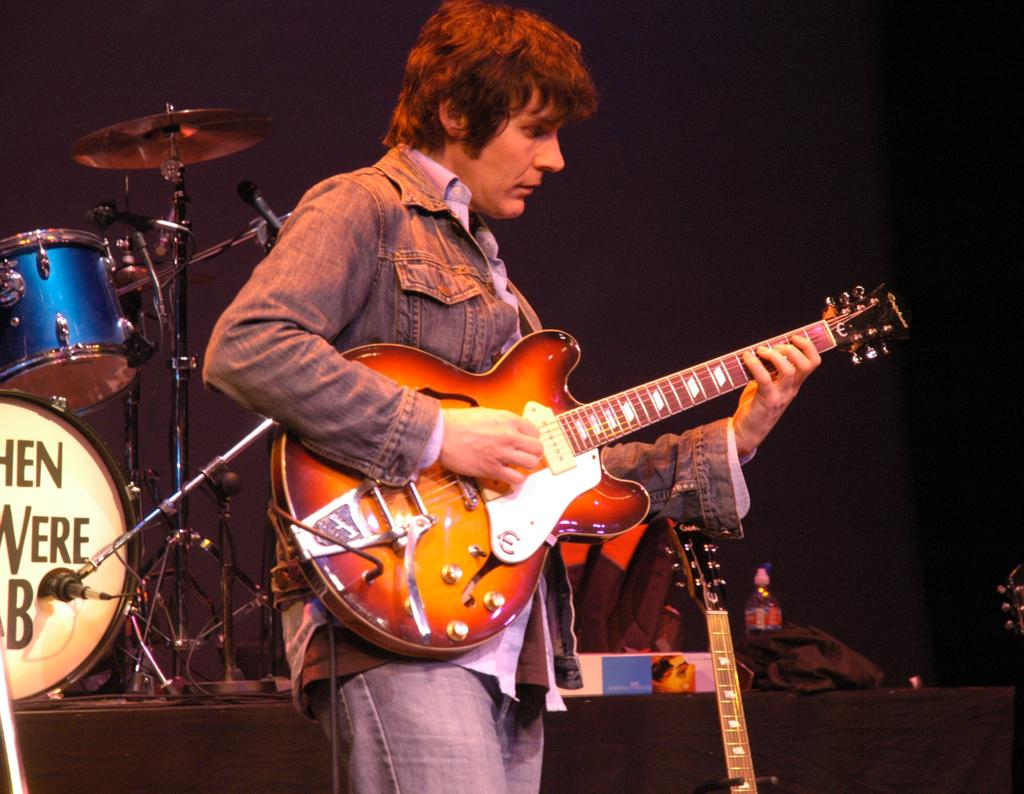What is the main activity of the person in the image? The person in the image is playing a guitar. Are there any other guitars visible in the image? Yes, there is another guitar beside the person. What other musical instrument can be seen in the image? There is a musical instrument behind the person. Can you describe the background of the image? The background of the image is dark. How many objects can be seen in the image besides the guitars and musical instruments? There are a few other objects in the image. What type of liquid is being poured into the food in the image? There is no liquid being poured into any food in the image; it features a person playing a guitar and other musical instruments. 